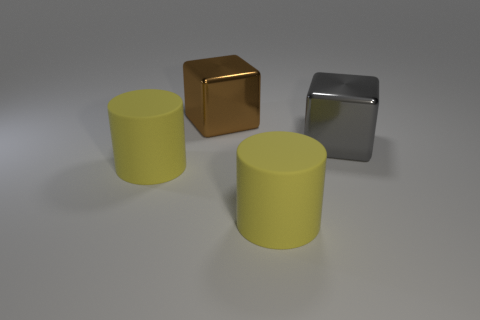Is the number of matte cylinders right of the brown object greater than the number of large rubber cylinders to the right of the large gray object?
Give a very brief answer. Yes. Do the big thing that is on the left side of the brown shiny thing and the big matte cylinder that is on the right side of the brown thing have the same color?
Your response must be concise. Yes. What shape is the brown shiny object?
Keep it short and to the point. Cube. Is the number of metal cubes that are in front of the brown block greater than the number of small gray shiny spheres?
Ensure brevity in your answer.  Yes. There is a brown metallic thing that is behind the big gray object; what is its shape?
Provide a short and direct response. Cube. What number of other things are there of the same shape as the brown thing?
Provide a succinct answer. 1. Is the big yellow thing that is left of the large brown shiny object made of the same material as the brown cube?
Provide a short and direct response. No. Are there the same number of shiny blocks in front of the gray cube and brown metal cubes that are in front of the large brown metal thing?
Offer a very short reply. Yes. There is a shiny object that is on the right side of the large brown thing; how big is it?
Give a very brief answer. Large. Are there any large blocks made of the same material as the gray object?
Keep it short and to the point. Yes. 